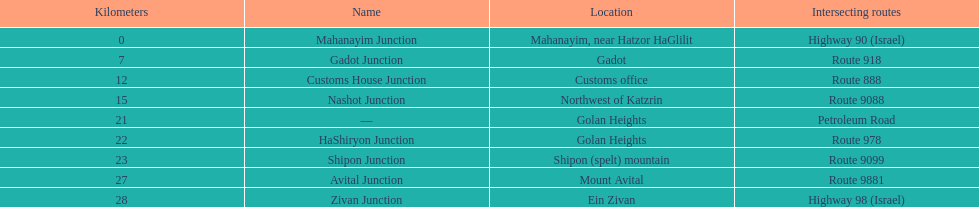On highway 91, is ein zivan closer to gadot junction or shipon junction? Gadot Junction. 